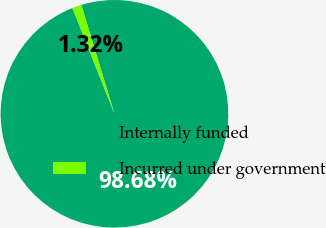Convert chart to OTSL. <chart><loc_0><loc_0><loc_500><loc_500><pie_chart><fcel>Internally funded<fcel>Incurred under government<nl><fcel>98.68%<fcel>1.32%<nl></chart> 